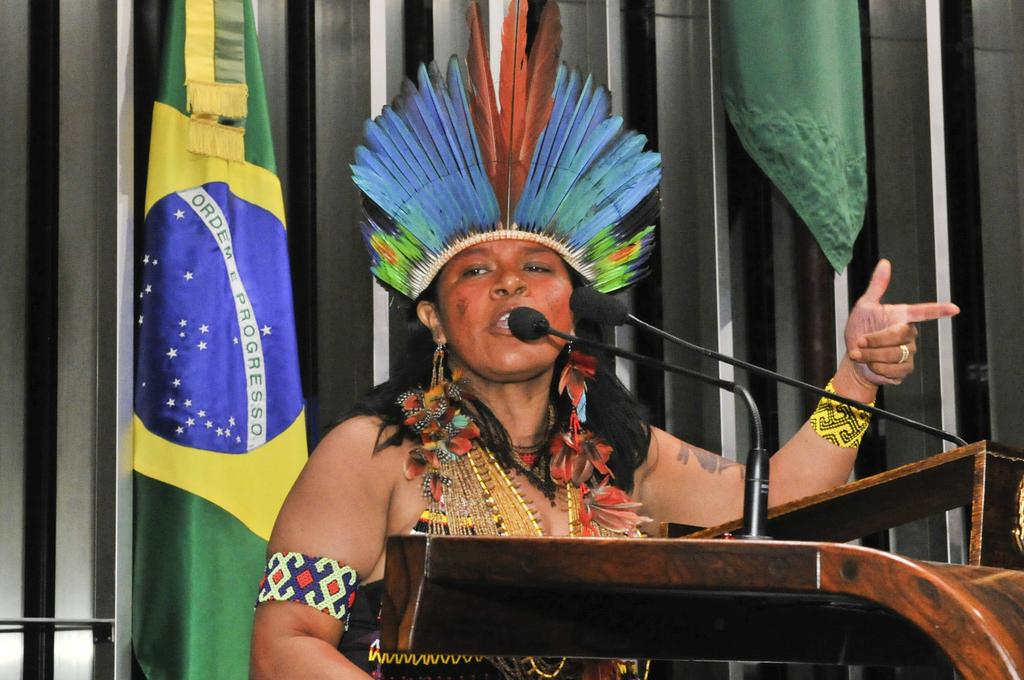What is the lady in the image doing? The lady is standing and speaking in the image. What is she wearing on her head? The lady is wearing a headgear with feathers. What can be seen in front of the lady? There is a stand with mics in front of the lady. What is visible in the background of the image? There is a flag visible in the background of the image. What type of marble is visible on the floor in the image? There is no marble visible on the floor in the image. What time of day is it in the image, considering the afternoon light? The time of day cannot be determined from the image, as there is no reference to lighting or shadows that would indicate a specific time. 